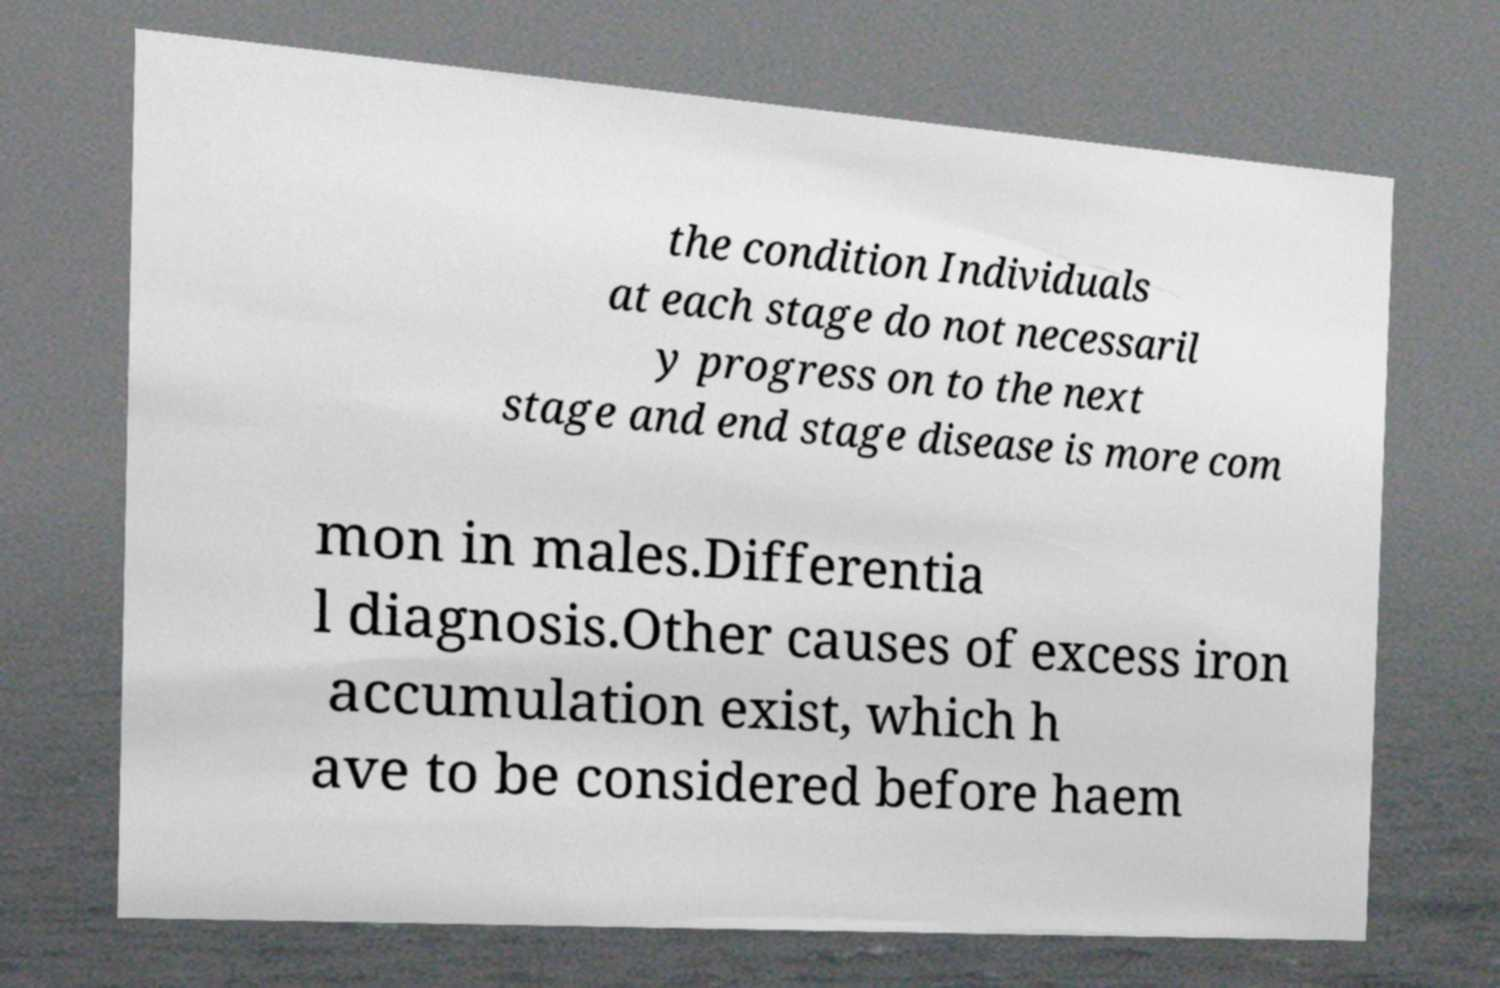What messages or text are displayed in this image? I need them in a readable, typed format. the condition Individuals at each stage do not necessaril y progress on to the next stage and end stage disease is more com mon in males.Differentia l diagnosis.Other causes of excess iron accumulation exist, which h ave to be considered before haem 